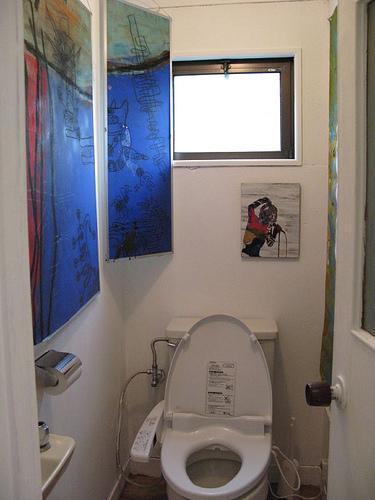How many toilets are in this picture?
Give a very brief answer. 1. How many windows are shown?
Give a very brief answer. 1. 